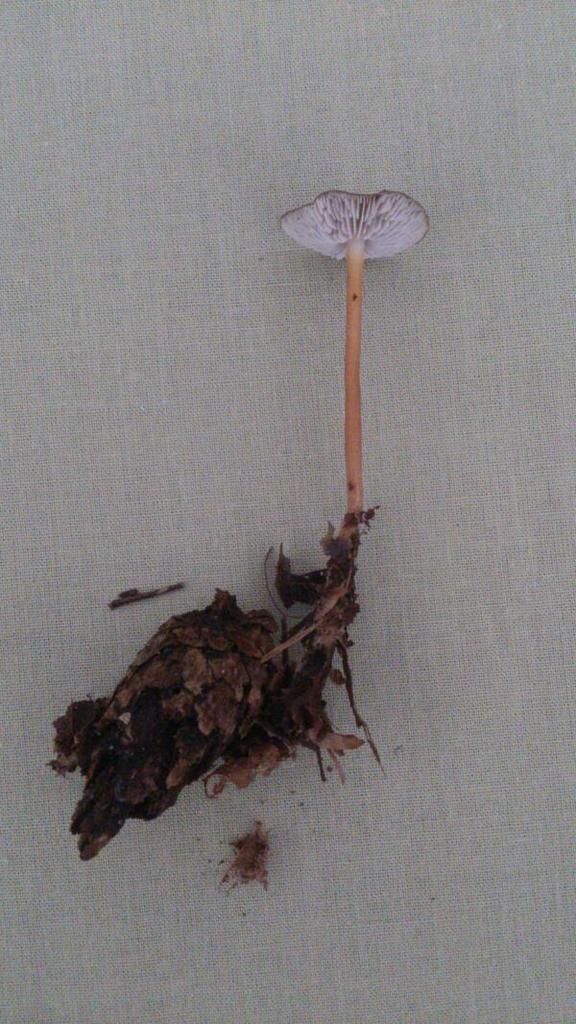In one or two sentences, can you explain what this image depicts? There is a plant with roots on a surface. And the background is cream in color. 